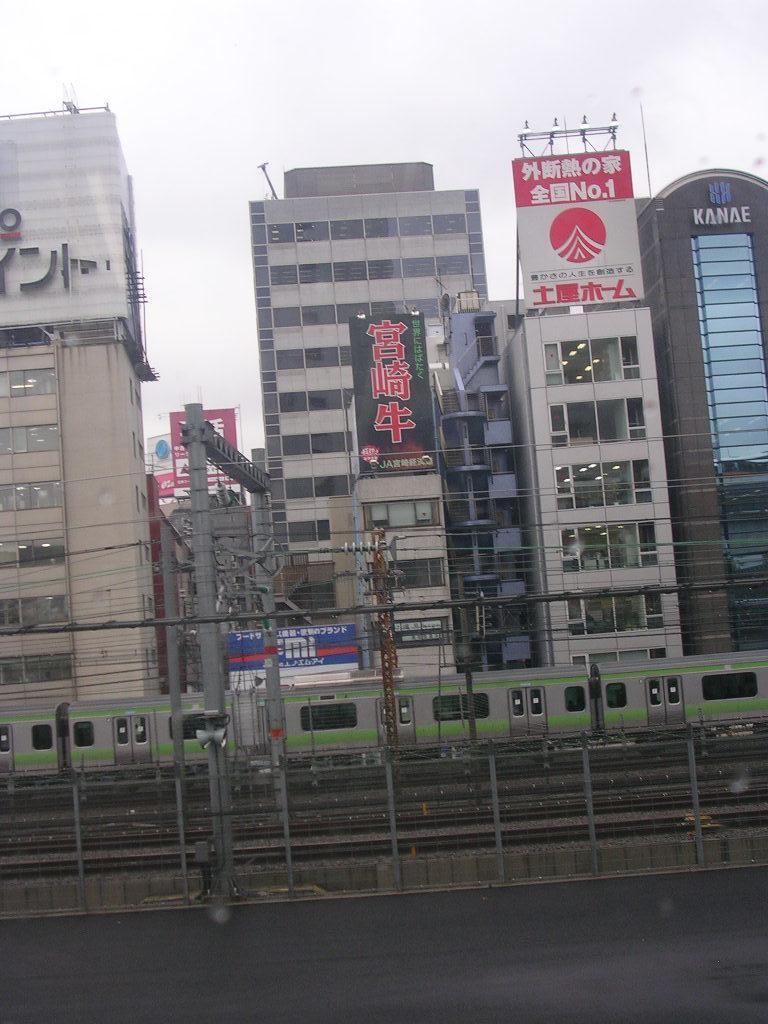Describe this image in one or two sentences. This image is taken outdoors. At the bottom of the image there is a road. In the middle of the image there is a pole with a few wires. There is a railing and a train is moving on the track. There are many buildings with walls, windows, doors and roofs and there are many boards with text on them. 